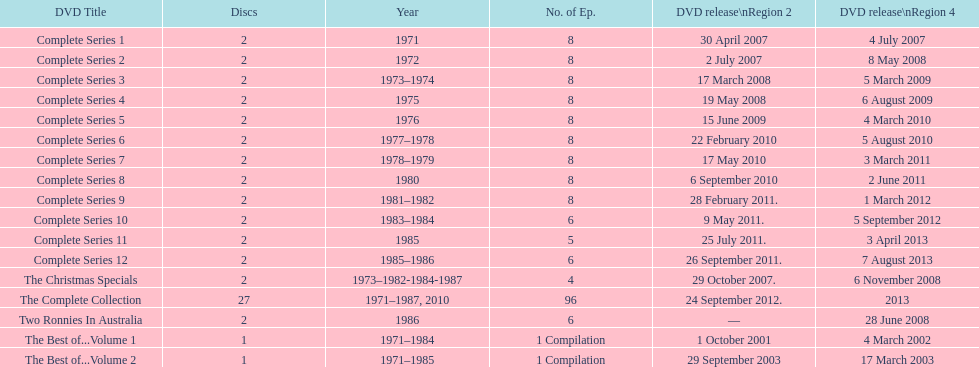In how many series were there 8 episodes? 9. 